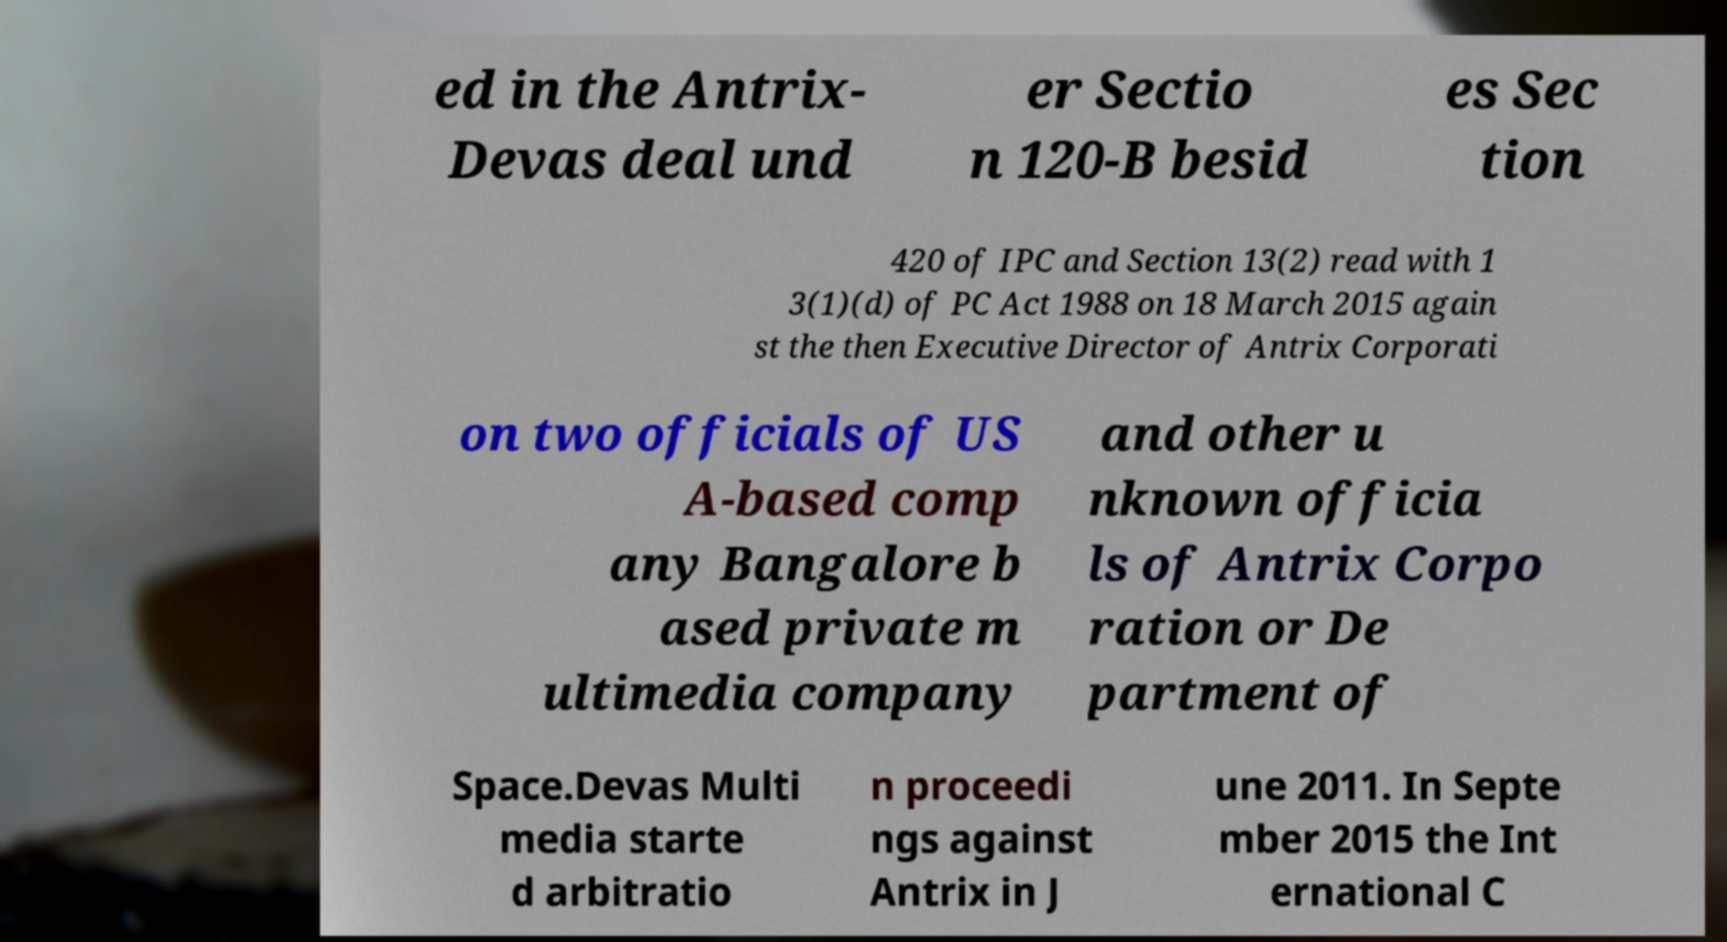Can you accurately transcribe the text from the provided image for me? ed in the Antrix- Devas deal und er Sectio n 120-B besid es Sec tion 420 of IPC and Section 13(2) read with 1 3(1)(d) of PC Act 1988 on 18 March 2015 again st the then Executive Director of Antrix Corporati on two officials of US A-based comp any Bangalore b ased private m ultimedia company and other u nknown officia ls of Antrix Corpo ration or De partment of Space.Devas Multi media starte d arbitratio n proceedi ngs against Antrix in J une 2011. In Septe mber 2015 the Int ernational C 